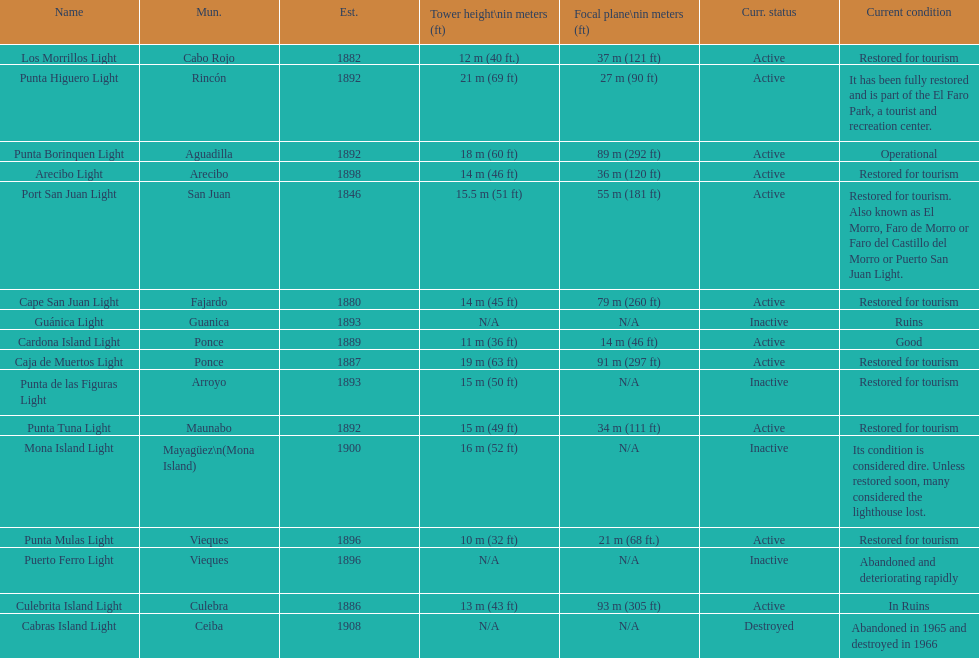Were any towers established before the year 1800? No. 